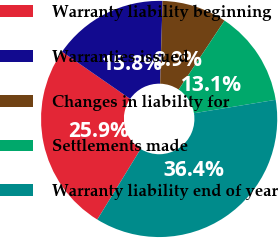Convert chart. <chart><loc_0><loc_0><loc_500><loc_500><pie_chart><fcel>Warranty liability beginning<fcel>Warranties issued<fcel>Changes in liability for<fcel>Settlements made<fcel>Warranty liability end of year<nl><fcel>25.87%<fcel>15.82%<fcel>8.88%<fcel>13.07%<fcel>36.37%<nl></chart> 